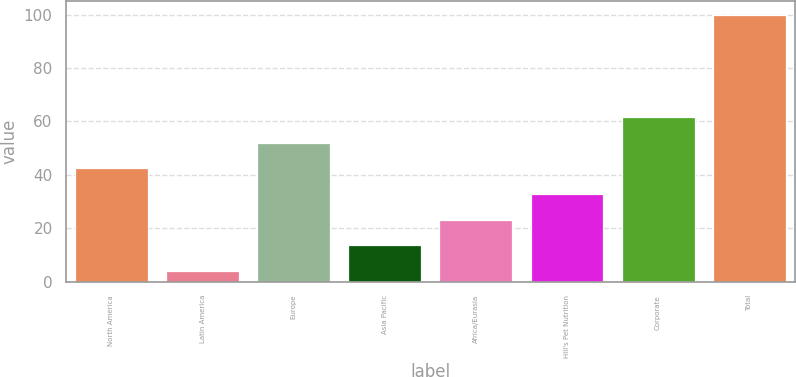<chart> <loc_0><loc_0><loc_500><loc_500><bar_chart><fcel>North America<fcel>Latin America<fcel>Europe<fcel>Asia Pacific<fcel>Africa/Eurasia<fcel>Hill's Pet Nutrition<fcel>Corporate<fcel>Total<nl><fcel>42.4<fcel>4<fcel>52<fcel>13.6<fcel>23.2<fcel>32.8<fcel>61.6<fcel>100<nl></chart> 